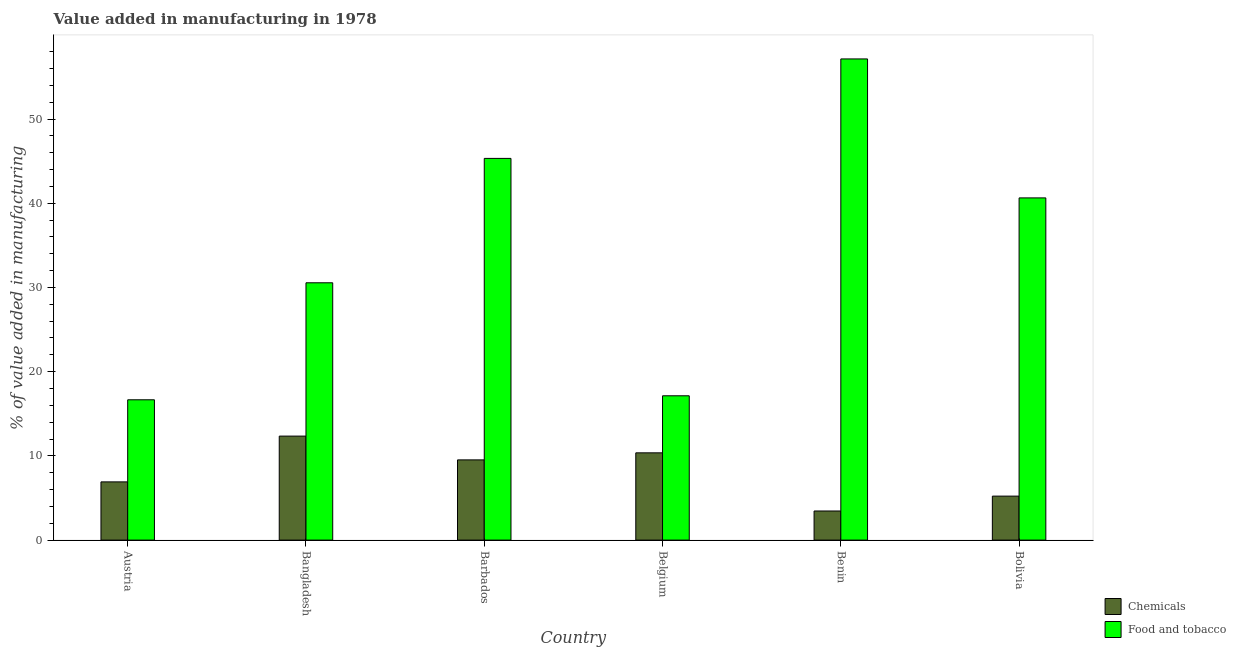How many groups of bars are there?
Your answer should be very brief. 6. Are the number of bars on each tick of the X-axis equal?
Your answer should be compact. Yes. How many bars are there on the 5th tick from the right?
Provide a short and direct response. 2. What is the label of the 4th group of bars from the left?
Provide a succinct answer. Belgium. In how many cases, is the number of bars for a given country not equal to the number of legend labels?
Your answer should be compact. 0. What is the value added by  manufacturing chemicals in Barbados?
Provide a short and direct response. 9.53. Across all countries, what is the maximum value added by manufacturing food and tobacco?
Offer a very short reply. 57.14. Across all countries, what is the minimum value added by manufacturing food and tobacco?
Give a very brief answer. 16.66. In which country was the value added by manufacturing food and tobacco minimum?
Ensure brevity in your answer.  Austria. What is the total value added by manufacturing food and tobacco in the graph?
Make the answer very short. 207.45. What is the difference between the value added by manufacturing food and tobacco in Belgium and that in Bolivia?
Your answer should be very brief. -23.5. What is the difference between the value added by  manufacturing chemicals in Benin and the value added by manufacturing food and tobacco in Barbados?
Your answer should be compact. -41.87. What is the average value added by manufacturing food and tobacco per country?
Make the answer very short. 34.58. What is the difference between the value added by  manufacturing chemicals and value added by manufacturing food and tobacco in Austria?
Give a very brief answer. -9.75. In how many countries, is the value added by manufacturing food and tobacco greater than 36 %?
Provide a succinct answer. 3. What is the ratio of the value added by  manufacturing chemicals in Benin to that in Bolivia?
Keep it short and to the point. 0.66. Is the value added by  manufacturing chemicals in Barbados less than that in Bolivia?
Make the answer very short. No. Is the difference between the value added by  manufacturing chemicals in Barbados and Bolivia greater than the difference between the value added by manufacturing food and tobacco in Barbados and Bolivia?
Provide a succinct answer. No. What is the difference between the highest and the second highest value added by manufacturing food and tobacco?
Make the answer very short. 11.81. What is the difference between the highest and the lowest value added by manufacturing food and tobacco?
Make the answer very short. 40.48. Is the sum of the value added by  manufacturing chemicals in Bangladesh and Barbados greater than the maximum value added by manufacturing food and tobacco across all countries?
Provide a short and direct response. No. What does the 1st bar from the left in Barbados represents?
Ensure brevity in your answer.  Chemicals. What does the 2nd bar from the right in Belgium represents?
Make the answer very short. Chemicals. How many bars are there?
Ensure brevity in your answer.  12. Are all the bars in the graph horizontal?
Give a very brief answer. No. How many countries are there in the graph?
Provide a succinct answer. 6. Are the values on the major ticks of Y-axis written in scientific E-notation?
Provide a short and direct response. No. Does the graph contain any zero values?
Offer a very short reply. No. How many legend labels are there?
Ensure brevity in your answer.  2. What is the title of the graph?
Give a very brief answer. Value added in manufacturing in 1978. Does "Working only" appear as one of the legend labels in the graph?
Provide a short and direct response. No. What is the label or title of the X-axis?
Give a very brief answer. Country. What is the label or title of the Y-axis?
Offer a very short reply. % of value added in manufacturing. What is the % of value added in manufacturing in Chemicals in Austria?
Your response must be concise. 6.91. What is the % of value added in manufacturing in Food and tobacco in Austria?
Your response must be concise. 16.66. What is the % of value added in manufacturing of Chemicals in Bangladesh?
Your answer should be compact. 12.35. What is the % of value added in manufacturing of Food and tobacco in Bangladesh?
Offer a very short reply. 30.56. What is the % of value added in manufacturing of Chemicals in Barbados?
Offer a very short reply. 9.53. What is the % of value added in manufacturing in Food and tobacco in Barbados?
Give a very brief answer. 45.33. What is the % of value added in manufacturing in Chemicals in Belgium?
Keep it short and to the point. 10.36. What is the % of value added in manufacturing of Food and tobacco in Belgium?
Offer a very short reply. 17.14. What is the % of value added in manufacturing of Chemicals in Benin?
Ensure brevity in your answer.  3.46. What is the % of value added in manufacturing of Food and tobacco in Benin?
Give a very brief answer. 57.14. What is the % of value added in manufacturing of Chemicals in Bolivia?
Give a very brief answer. 5.22. What is the % of value added in manufacturing in Food and tobacco in Bolivia?
Keep it short and to the point. 40.64. Across all countries, what is the maximum % of value added in manufacturing in Chemicals?
Give a very brief answer. 12.35. Across all countries, what is the maximum % of value added in manufacturing of Food and tobacco?
Provide a short and direct response. 57.14. Across all countries, what is the minimum % of value added in manufacturing in Chemicals?
Your answer should be compact. 3.46. Across all countries, what is the minimum % of value added in manufacturing in Food and tobacco?
Give a very brief answer. 16.66. What is the total % of value added in manufacturing of Chemicals in the graph?
Provide a short and direct response. 47.83. What is the total % of value added in manufacturing in Food and tobacco in the graph?
Offer a terse response. 207.45. What is the difference between the % of value added in manufacturing in Chemicals in Austria and that in Bangladesh?
Provide a short and direct response. -5.44. What is the difference between the % of value added in manufacturing of Food and tobacco in Austria and that in Bangladesh?
Your response must be concise. -13.89. What is the difference between the % of value added in manufacturing of Chemicals in Austria and that in Barbados?
Offer a very short reply. -2.61. What is the difference between the % of value added in manufacturing of Food and tobacco in Austria and that in Barbados?
Give a very brief answer. -28.67. What is the difference between the % of value added in manufacturing in Chemicals in Austria and that in Belgium?
Provide a succinct answer. -3.45. What is the difference between the % of value added in manufacturing of Food and tobacco in Austria and that in Belgium?
Your answer should be compact. -0.48. What is the difference between the % of value added in manufacturing in Chemicals in Austria and that in Benin?
Give a very brief answer. 3.46. What is the difference between the % of value added in manufacturing in Food and tobacco in Austria and that in Benin?
Ensure brevity in your answer.  -40.48. What is the difference between the % of value added in manufacturing in Chemicals in Austria and that in Bolivia?
Ensure brevity in your answer.  1.69. What is the difference between the % of value added in manufacturing in Food and tobacco in Austria and that in Bolivia?
Offer a very short reply. -23.97. What is the difference between the % of value added in manufacturing of Chemicals in Bangladesh and that in Barbados?
Your response must be concise. 2.82. What is the difference between the % of value added in manufacturing of Food and tobacco in Bangladesh and that in Barbados?
Provide a short and direct response. -14.77. What is the difference between the % of value added in manufacturing of Chemicals in Bangladesh and that in Belgium?
Your response must be concise. 1.99. What is the difference between the % of value added in manufacturing in Food and tobacco in Bangladesh and that in Belgium?
Your answer should be very brief. 13.42. What is the difference between the % of value added in manufacturing in Chemicals in Bangladesh and that in Benin?
Offer a terse response. 8.89. What is the difference between the % of value added in manufacturing of Food and tobacco in Bangladesh and that in Benin?
Ensure brevity in your answer.  -26.58. What is the difference between the % of value added in manufacturing in Chemicals in Bangladesh and that in Bolivia?
Ensure brevity in your answer.  7.13. What is the difference between the % of value added in manufacturing of Food and tobacco in Bangladesh and that in Bolivia?
Ensure brevity in your answer.  -10.08. What is the difference between the % of value added in manufacturing of Chemicals in Barbados and that in Belgium?
Keep it short and to the point. -0.84. What is the difference between the % of value added in manufacturing of Food and tobacco in Barbados and that in Belgium?
Provide a succinct answer. 28.19. What is the difference between the % of value added in manufacturing in Chemicals in Barbados and that in Benin?
Provide a short and direct response. 6.07. What is the difference between the % of value added in manufacturing in Food and tobacco in Barbados and that in Benin?
Offer a very short reply. -11.81. What is the difference between the % of value added in manufacturing of Chemicals in Barbados and that in Bolivia?
Provide a short and direct response. 4.3. What is the difference between the % of value added in manufacturing in Food and tobacco in Barbados and that in Bolivia?
Give a very brief answer. 4.69. What is the difference between the % of value added in manufacturing of Chemicals in Belgium and that in Benin?
Keep it short and to the point. 6.9. What is the difference between the % of value added in manufacturing in Food and tobacco in Belgium and that in Benin?
Make the answer very short. -40. What is the difference between the % of value added in manufacturing in Chemicals in Belgium and that in Bolivia?
Provide a short and direct response. 5.14. What is the difference between the % of value added in manufacturing of Food and tobacco in Belgium and that in Bolivia?
Ensure brevity in your answer.  -23.5. What is the difference between the % of value added in manufacturing of Chemicals in Benin and that in Bolivia?
Your answer should be very brief. -1.77. What is the difference between the % of value added in manufacturing of Food and tobacco in Benin and that in Bolivia?
Your response must be concise. 16.5. What is the difference between the % of value added in manufacturing of Chemicals in Austria and the % of value added in manufacturing of Food and tobacco in Bangladesh?
Your answer should be very brief. -23.64. What is the difference between the % of value added in manufacturing in Chemicals in Austria and the % of value added in manufacturing in Food and tobacco in Barbados?
Offer a terse response. -38.41. What is the difference between the % of value added in manufacturing of Chemicals in Austria and the % of value added in manufacturing of Food and tobacco in Belgium?
Your answer should be very brief. -10.22. What is the difference between the % of value added in manufacturing of Chemicals in Austria and the % of value added in manufacturing of Food and tobacco in Benin?
Make the answer very short. -50.22. What is the difference between the % of value added in manufacturing in Chemicals in Austria and the % of value added in manufacturing in Food and tobacco in Bolivia?
Give a very brief answer. -33.72. What is the difference between the % of value added in manufacturing of Chemicals in Bangladesh and the % of value added in manufacturing of Food and tobacco in Barbados?
Make the answer very short. -32.98. What is the difference between the % of value added in manufacturing of Chemicals in Bangladesh and the % of value added in manufacturing of Food and tobacco in Belgium?
Make the answer very short. -4.79. What is the difference between the % of value added in manufacturing in Chemicals in Bangladesh and the % of value added in manufacturing in Food and tobacco in Benin?
Your answer should be compact. -44.79. What is the difference between the % of value added in manufacturing in Chemicals in Bangladesh and the % of value added in manufacturing in Food and tobacco in Bolivia?
Make the answer very short. -28.29. What is the difference between the % of value added in manufacturing in Chemicals in Barbados and the % of value added in manufacturing in Food and tobacco in Belgium?
Your answer should be very brief. -7.61. What is the difference between the % of value added in manufacturing in Chemicals in Barbados and the % of value added in manufacturing in Food and tobacco in Benin?
Ensure brevity in your answer.  -47.61. What is the difference between the % of value added in manufacturing of Chemicals in Barbados and the % of value added in manufacturing of Food and tobacco in Bolivia?
Make the answer very short. -31.11. What is the difference between the % of value added in manufacturing of Chemicals in Belgium and the % of value added in manufacturing of Food and tobacco in Benin?
Provide a short and direct response. -46.78. What is the difference between the % of value added in manufacturing of Chemicals in Belgium and the % of value added in manufacturing of Food and tobacco in Bolivia?
Your answer should be compact. -30.27. What is the difference between the % of value added in manufacturing in Chemicals in Benin and the % of value added in manufacturing in Food and tobacco in Bolivia?
Give a very brief answer. -37.18. What is the average % of value added in manufacturing of Chemicals per country?
Offer a very short reply. 7.97. What is the average % of value added in manufacturing of Food and tobacco per country?
Provide a succinct answer. 34.58. What is the difference between the % of value added in manufacturing of Chemicals and % of value added in manufacturing of Food and tobacco in Austria?
Ensure brevity in your answer.  -9.75. What is the difference between the % of value added in manufacturing of Chemicals and % of value added in manufacturing of Food and tobacco in Bangladesh?
Provide a short and direct response. -18.21. What is the difference between the % of value added in manufacturing of Chemicals and % of value added in manufacturing of Food and tobacco in Barbados?
Offer a terse response. -35.8. What is the difference between the % of value added in manufacturing of Chemicals and % of value added in manufacturing of Food and tobacco in Belgium?
Your answer should be compact. -6.77. What is the difference between the % of value added in manufacturing in Chemicals and % of value added in manufacturing in Food and tobacco in Benin?
Give a very brief answer. -53.68. What is the difference between the % of value added in manufacturing of Chemicals and % of value added in manufacturing of Food and tobacco in Bolivia?
Your answer should be compact. -35.41. What is the ratio of the % of value added in manufacturing in Chemicals in Austria to that in Bangladesh?
Provide a short and direct response. 0.56. What is the ratio of the % of value added in manufacturing in Food and tobacco in Austria to that in Bangladesh?
Your answer should be very brief. 0.55. What is the ratio of the % of value added in manufacturing in Chemicals in Austria to that in Barbados?
Your answer should be compact. 0.73. What is the ratio of the % of value added in manufacturing in Food and tobacco in Austria to that in Barbados?
Keep it short and to the point. 0.37. What is the ratio of the % of value added in manufacturing in Chemicals in Austria to that in Belgium?
Make the answer very short. 0.67. What is the ratio of the % of value added in manufacturing in Food and tobacco in Austria to that in Belgium?
Keep it short and to the point. 0.97. What is the ratio of the % of value added in manufacturing of Chemicals in Austria to that in Benin?
Your answer should be compact. 2. What is the ratio of the % of value added in manufacturing of Food and tobacco in Austria to that in Benin?
Ensure brevity in your answer.  0.29. What is the ratio of the % of value added in manufacturing in Chemicals in Austria to that in Bolivia?
Your response must be concise. 1.32. What is the ratio of the % of value added in manufacturing in Food and tobacco in Austria to that in Bolivia?
Keep it short and to the point. 0.41. What is the ratio of the % of value added in manufacturing of Chemicals in Bangladesh to that in Barbados?
Your answer should be very brief. 1.3. What is the ratio of the % of value added in manufacturing of Food and tobacco in Bangladesh to that in Barbados?
Provide a succinct answer. 0.67. What is the ratio of the % of value added in manufacturing of Chemicals in Bangladesh to that in Belgium?
Ensure brevity in your answer.  1.19. What is the ratio of the % of value added in manufacturing in Food and tobacco in Bangladesh to that in Belgium?
Offer a very short reply. 1.78. What is the ratio of the % of value added in manufacturing in Chemicals in Bangladesh to that in Benin?
Provide a succinct answer. 3.57. What is the ratio of the % of value added in manufacturing in Food and tobacco in Bangladesh to that in Benin?
Your response must be concise. 0.53. What is the ratio of the % of value added in manufacturing of Chemicals in Bangladesh to that in Bolivia?
Offer a terse response. 2.36. What is the ratio of the % of value added in manufacturing in Food and tobacco in Bangladesh to that in Bolivia?
Your answer should be very brief. 0.75. What is the ratio of the % of value added in manufacturing of Chemicals in Barbados to that in Belgium?
Offer a very short reply. 0.92. What is the ratio of the % of value added in manufacturing of Food and tobacco in Barbados to that in Belgium?
Offer a very short reply. 2.65. What is the ratio of the % of value added in manufacturing of Chemicals in Barbados to that in Benin?
Keep it short and to the point. 2.76. What is the ratio of the % of value added in manufacturing in Food and tobacco in Barbados to that in Benin?
Your answer should be compact. 0.79. What is the ratio of the % of value added in manufacturing of Chemicals in Barbados to that in Bolivia?
Provide a succinct answer. 1.82. What is the ratio of the % of value added in manufacturing in Food and tobacco in Barbados to that in Bolivia?
Offer a terse response. 1.12. What is the ratio of the % of value added in manufacturing of Chemicals in Belgium to that in Benin?
Make the answer very short. 3. What is the ratio of the % of value added in manufacturing of Food and tobacco in Belgium to that in Benin?
Offer a very short reply. 0.3. What is the ratio of the % of value added in manufacturing in Chemicals in Belgium to that in Bolivia?
Provide a succinct answer. 1.98. What is the ratio of the % of value added in manufacturing in Food and tobacco in Belgium to that in Bolivia?
Keep it short and to the point. 0.42. What is the ratio of the % of value added in manufacturing in Chemicals in Benin to that in Bolivia?
Make the answer very short. 0.66. What is the ratio of the % of value added in manufacturing in Food and tobacco in Benin to that in Bolivia?
Provide a succinct answer. 1.41. What is the difference between the highest and the second highest % of value added in manufacturing in Chemicals?
Offer a terse response. 1.99. What is the difference between the highest and the second highest % of value added in manufacturing of Food and tobacco?
Make the answer very short. 11.81. What is the difference between the highest and the lowest % of value added in manufacturing of Chemicals?
Provide a succinct answer. 8.89. What is the difference between the highest and the lowest % of value added in manufacturing in Food and tobacco?
Make the answer very short. 40.48. 